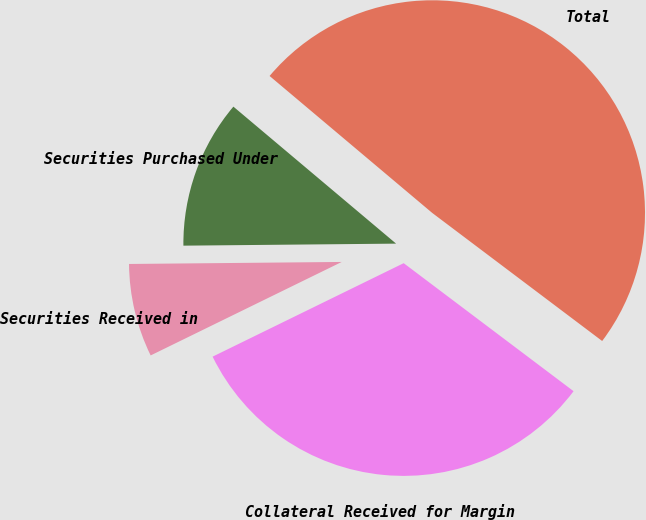Convert chart. <chart><loc_0><loc_0><loc_500><loc_500><pie_chart><fcel>Securities Purchased Under<fcel>Securities Received in<fcel>Collateral Received for Margin<fcel>Total<nl><fcel>11.29%<fcel>7.09%<fcel>32.48%<fcel>49.14%<nl></chart> 